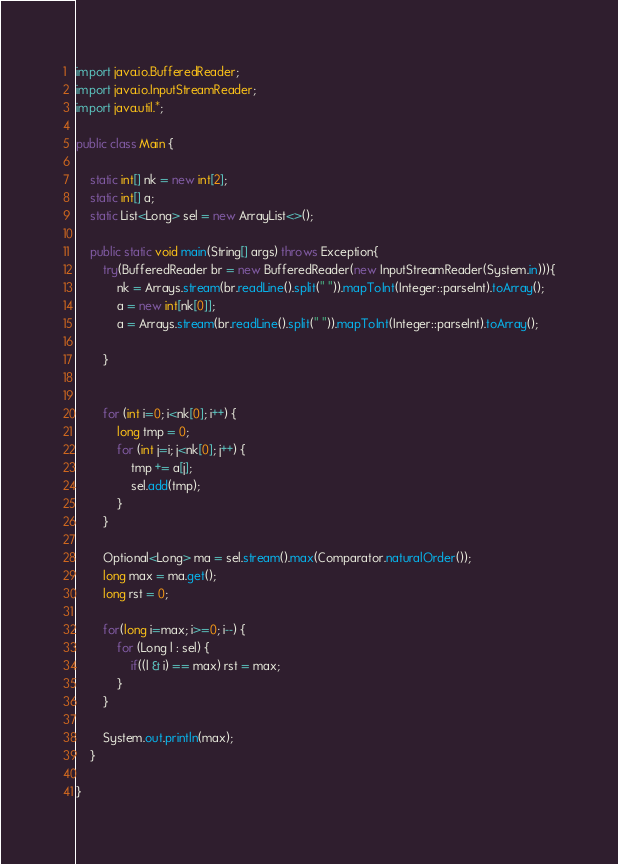<code> <loc_0><loc_0><loc_500><loc_500><_Java_>
import java.io.BufferedReader;
import java.io.InputStreamReader;
import java.util.*;

public class Main {

	static int[] nk = new int[2];
	static int[] a; 
	static List<Long> sel = new ArrayList<>();
	
	public static void main(String[] args) throws Exception{
		try(BufferedReader br = new BufferedReader(new InputStreamReader(System.in))){
			nk = Arrays.stream(br.readLine().split(" ")).mapToInt(Integer::parseInt).toArray();
			a = new int[nk[0]];
			a = Arrays.stream(br.readLine().split(" ")).mapToInt(Integer::parseInt).toArray();
			
		}
		
		
		for (int i=0; i<nk[0]; i++) {
			long tmp = 0;
			for (int j=i; j<nk[0]; j++) {
				tmp += a[j];
				sel.add(tmp);
			}
		}
		
		Optional<Long> ma = sel.stream().max(Comparator.naturalOrder());
		long max = ma.get();
		long rst = 0;
		
		for(long i=max; i>=0; i--) {
			for (Long l : sel) {
				if((l & i) == max) rst = max;
			}
		}
		
		System.out.println(max);
	}

}
</code> 